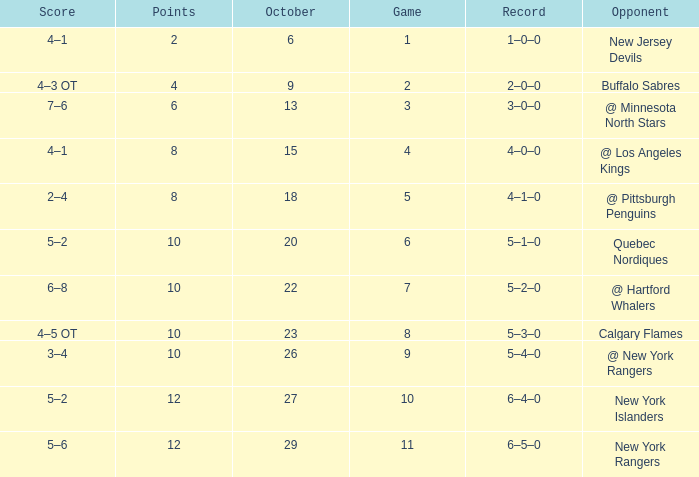How many Points have an Opponent of @ los angeles kings and a Game larger than 4? None. Would you mind parsing the complete table? {'header': ['Score', 'Points', 'October', 'Game', 'Record', 'Opponent'], 'rows': [['4–1', '2', '6', '1', '1–0–0', 'New Jersey Devils'], ['4–3 OT', '4', '9', '2', '2–0–0', 'Buffalo Sabres'], ['7–6', '6', '13', '3', '3–0–0', '@ Minnesota North Stars'], ['4–1', '8', '15', '4', '4–0–0', '@ Los Angeles Kings'], ['2–4', '8', '18', '5', '4–1–0', '@ Pittsburgh Penguins'], ['5–2', '10', '20', '6', '5–1–0', 'Quebec Nordiques'], ['6–8', '10', '22', '7', '5–2–0', '@ Hartford Whalers'], ['4–5 OT', '10', '23', '8', '5–3–0', 'Calgary Flames'], ['3–4', '10', '26', '9', '5–4–0', '@ New York Rangers'], ['5–2', '12', '27', '10', '6–4–0', 'New York Islanders'], ['5–6', '12', '29', '11', '6–5–0', 'New York Rangers']]} 